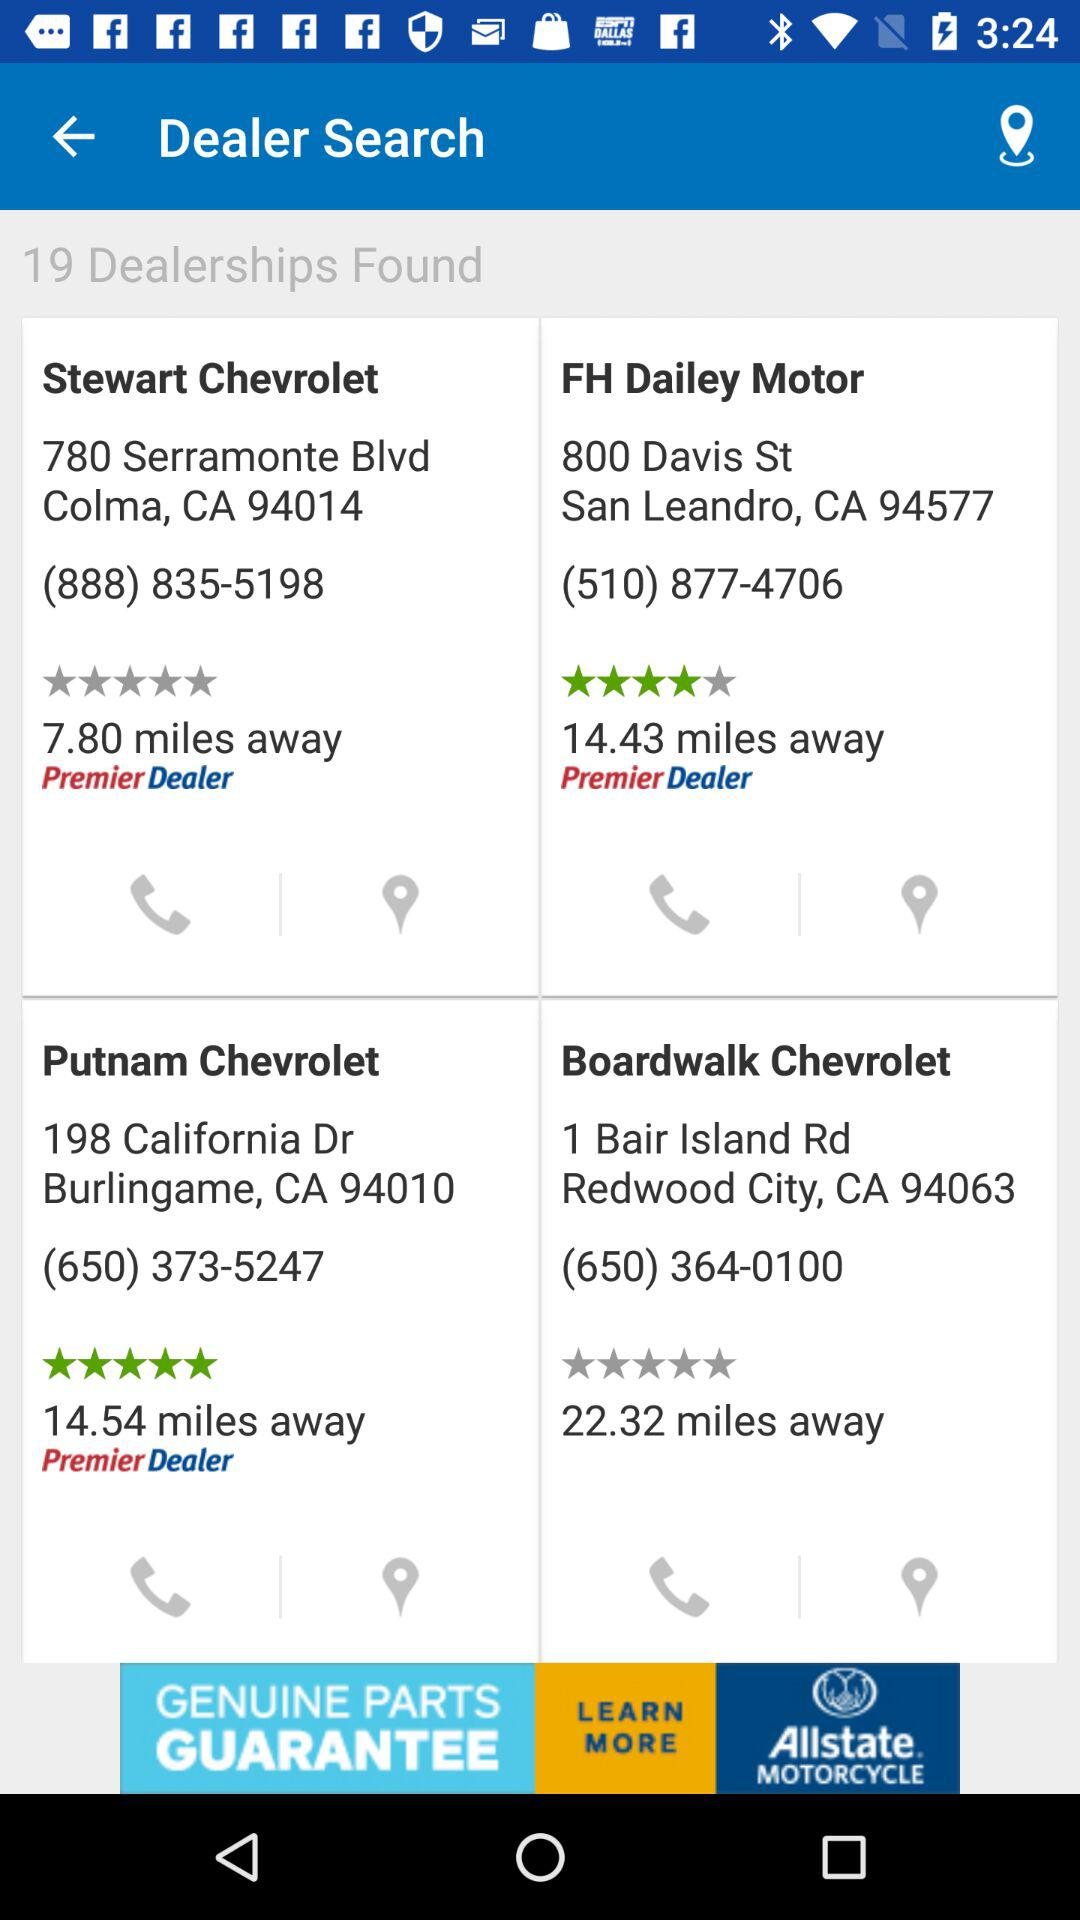What is the contact number for "Stewart Chevrolet"? The contact number for "Stewart Chevrolet" is (888) 835-5198. 